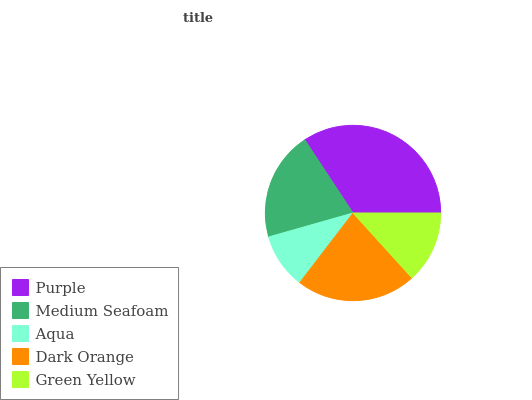Is Aqua the minimum?
Answer yes or no. Yes. Is Purple the maximum?
Answer yes or no. Yes. Is Medium Seafoam the minimum?
Answer yes or no. No. Is Medium Seafoam the maximum?
Answer yes or no. No. Is Purple greater than Medium Seafoam?
Answer yes or no. Yes. Is Medium Seafoam less than Purple?
Answer yes or no. Yes. Is Medium Seafoam greater than Purple?
Answer yes or no. No. Is Purple less than Medium Seafoam?
Answer yes or no. No. Is Medium Seafoam the high median?
Answer yes or no. Yes. Is Medium Seafoam the low median?
Answer yes or no. Yes. Is Dark Orange the high median?
Answer yes or no. No. Is Green Yellow the low median?
Answer yes or no. No. 